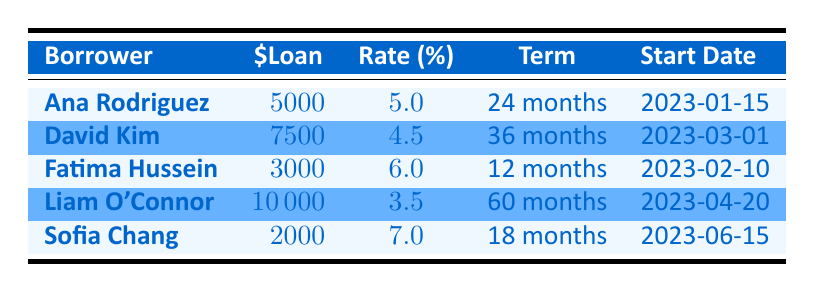What is the loan amount for Ana Rodriguez? Ana Rodriguez's loan details can be found on the first row of the table. The column labeled "$Loan" indicates that her loan amount is 5000.
Answer: 5000 What is the interest rate for David Kim's loan? David Kim's interest rate is listed in the third column of his row, which shows 4.5.
Answer: 4.5 Which borrower has the shortest loan term? Looking through the "Term" column, Fatima Hussein has the shortest loan term of 12 months.
Answer: Fatima Hussein Is the loan amount for Liam O'Connor greater than 8000? The loan amount for Liam O'Connor is 10000, which is indeed greater than 8000.
Answer: Yes What is the average interest rate of all the loans? To find the average interest rate, we add the rates: 5 + 4.5 + 6 + 3.5 + 7 = 26. Then we divide by the number of borrowers (5): 26 / 5 = 5.2.
Answer: 5.2 What is the total loan amount given to all borrowers? The total loan amount is found by summing all the amounts: 5000 + 7500 + 3000 + 10000 + 2000 = 30000.
Answer: 30000 Which borrower received a loan with an interest rate of 7 percent? The borrower with an interest rate of 7 percent, as per the table, is Sofia Chang.
Answer: Sofia Chang How many borrowers have a loan term of at least 24 months? The borrowers with loan terms of at least 24 months can be found by examining the "Term" column: Ana Rodriguez (24 months), David Kim (36 months), and Liam O'Connor (60 months). This gives us a total of 3 borrowers.
Answer: 3 Was Fatima Hussein's loan amount less than 5000? The loan amount for Fatima Hussein is 3000, which is less than 5000.
Answer: Yes What is the difference in loan amounts between Liam O'Connor and Sofia Chang? Liam O'Connor's loan amount is 10000, while Sofia Chang's is 2000. The difference is calculated as 10000 - 2000 = 8000.
Answer: 8000 